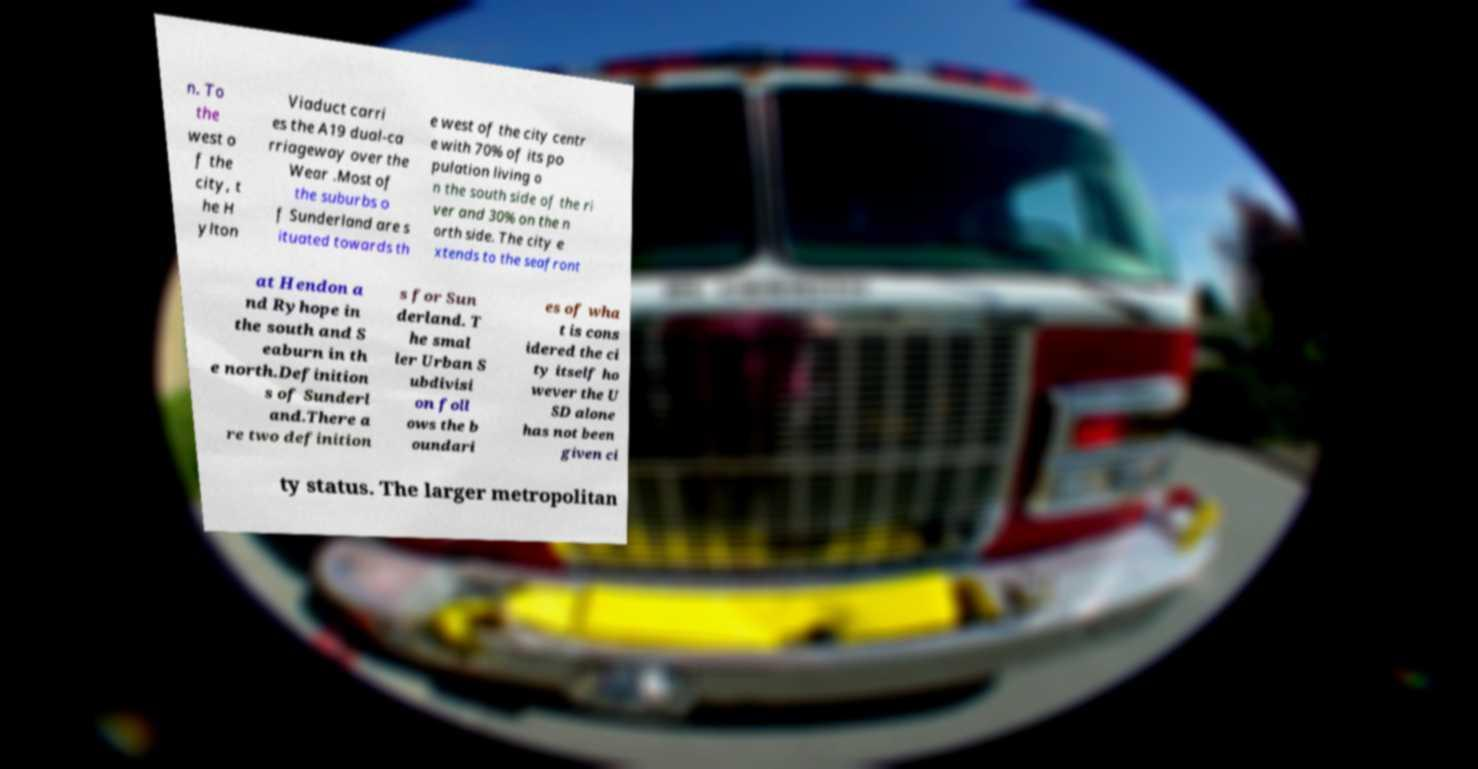I need the written content from this picture converted into text. Can you do that? n. To the west o f the city, t he H ylton Viaduct carri es the A19 dual-ca rriageway over the Wear .Most of the suburbs o f Sunderland are s ituated towards th e west of the city centr e with 70% of its po pulation living o n the south side of the ri ver and 30% on the n orth side. The city e xtends to the seafront at Hendon a nd Ryhope in the south and S eaburn in th e north.Definition s of Sunderl and.There a re two definition s for Sun derland. T he smal ler Urban S ubdivisi on foll ows the b oundari es of wha t is cons idered the ci ty itself ho wever the U SD alone has not been given ci ty status. The larger metropolitan 